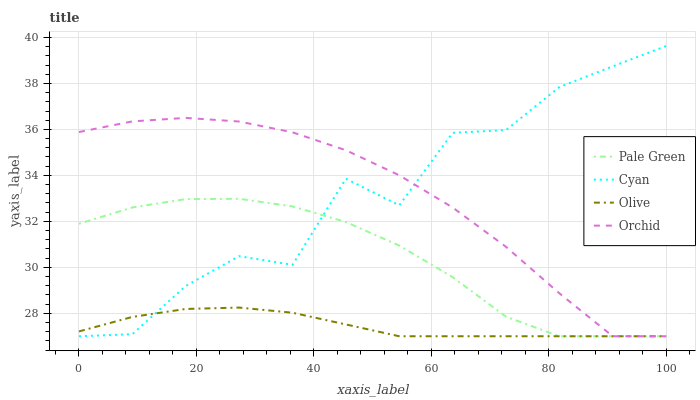Does Olive have the minimum area under the curve?
Answer yes or no. Yes. Does Cyan have the maximum area under the curve?
Answer yes or no. Yes. Does Pale Green have the minimum area under the curve?
Answer yes or no. No. Does Pale Green have the maximum area under the curve?
Answer yes or no. No. Is Olive the smoothest?
Answer yes or no. Yes. Is Cyan the roughest?
Answer yes or no. Yes. Is Pale Green the smoothest?
Answer yes or no. No. Is Pale Green the roughest?
Answer yes or no. No. Does Olive have the lowest value?
Answer yes or no. Yes. Does Cyan have the highest value?
Answer yes or no. Yes. Does Pale Green have the highest value?
Answer yes or no. No. Does Olive intersect Cyan?
Answer yes or no. Yes. Is Olive less than Cyan?
Answer yes or no. No. Is Olive greater than Cyan?
Answer yes or no. No. 